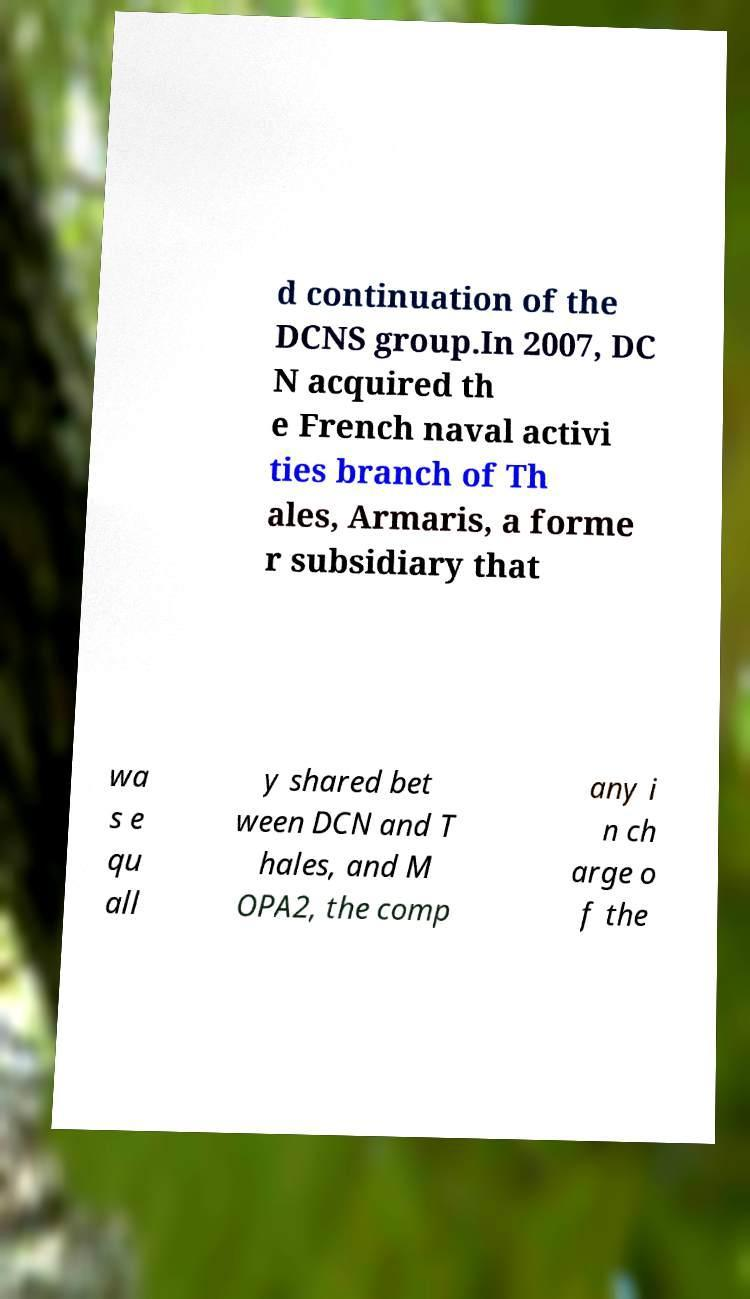What messages or text are displayed in this image? I need them in a readable, typed format. d continuation of the DCNS group.In 2007, DC N acquired th e French naval activi ties branch of Th ales, Armaris, a forme r subsidiary that wa s e qu all y shared bet ween DCN and T hales, and M OPA2, the comp any i n ch arge o f the 